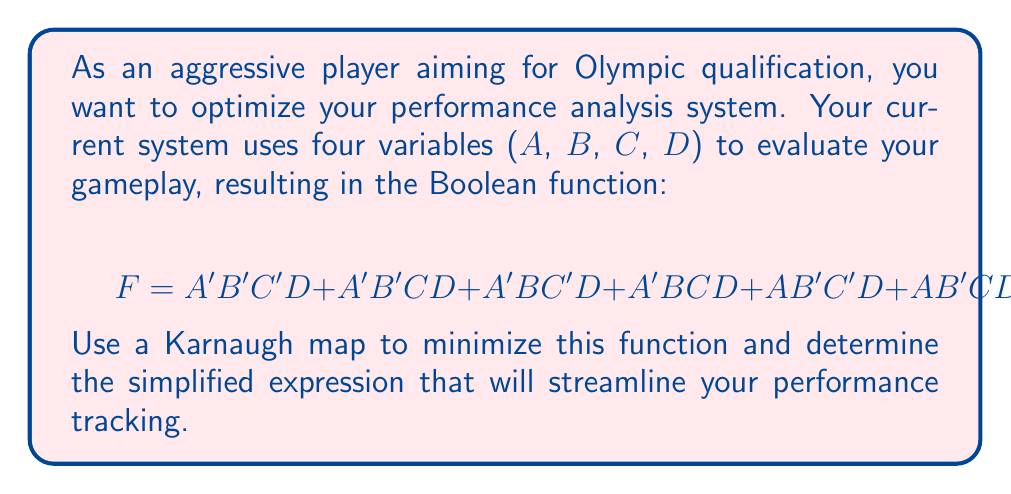Can you solve this math problem? 1) First, we'll create a 4-variable Karnaugh map:

[asy]
unitsize(1cm);
draw((0,0)--(4,0)--(4,4)--(0,4)--cycle);
draw((0,1)--(4,1));
draw((0,2)--(4,2));
draw((0,3)--(4,3));
draw((1,0)--(1,4));
draw((2,0)--(2,4));
draw((3,0)--(3,4));
label("00", (0.5,4.5));
label("01", (1.5,4.5));
label("11", (2.5,4.5));
label("10", (3.5,4.5));
label("00", (-0.5,3.5));
label("01", (-0.5,2.5));
label("11", (-0.5,1.5));
label("10", (-0.5,0.5));
label("AB", (-0.5,4.5));
label("CD", (4.5,4.5));
label("1", (0.5,3.5));
label("1", (1.5,3.5));
label("1", (2.5,3.5));
label("1", (3.5,3.5));
label("1", (0.5,2.5));
label("1", (1.5,2.5));
label("1", (2.5,2.5));
[/asy]

2) We've filled in 1's for each minterm in the given function.

3) Now, we look for the largest possible groupings of 1's. In this case, we can see:
   - A group of 4 in the top row (CD = 00, 01, 11, 10 when AB = 00)
   - A group of 4 in the right column (AB = 00, 01, 11, 10 when CD = 11)

4) These groupings correspond to the following terms:
   - Top row: $A'B'D$
   - Right column: $CD$

5) The minimized function is the OR of these terms:

   $F_{min} = A'B'D + CD$

This simplified expression reduces the original 7-term function to just 2 terms, significantly streamlining the performance tracking system.
Answer: $A'B'D + CD$ 